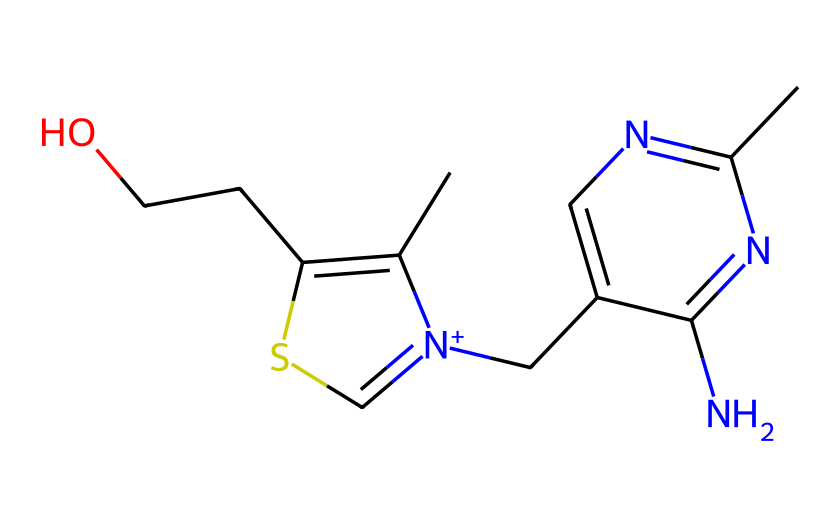What is the main functional group present in thiamine? The presence of sulfur in the structure indicates a thiol or thioether functional group. Here, the -S- (sulfur) linked to carbons suggests the presence of a thioether functional group.
Answer: thioether How many nitrogen atoms are in thiamine? By examining the structure, there are two distinct nitrogen atoms incorporated into the molecule, which are part of the aromatic and amine groups.
Answer: two What is the molecular formula of thiamine? Counting the individual atoms in the structure derived from the SMILES notation gives the formula C12H17N4OS. This includes 12 carbons, 17 hydrogens, 4 nitrogens, 1 oxygen, and 1 sulfur.
Answer: C12H17N4OS How many rings are present in the structure of thiamine? The structure reveals there are two cyclic components, identified as rings within the compound. This includes one five-membered and one six-membered ring.
Answer: two Is thiamine soluble in water? Thiamine is a polar molecule due to the presence of the multiple functional groups, such as amine and thioether, which enhance its solubility in water.
Answer: yes What type of organosulfur compound is thiamine classified as? Thiamine is classified as a thiamine or vitamin, characterized by its organosulfur structure, specifically containing a thiazole ring, which is a typical feature of this chemical type.
Answer: vitamin 